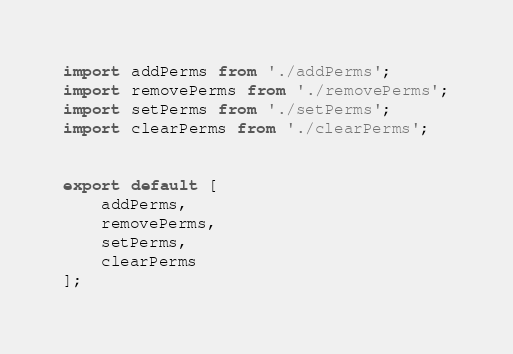Convert code to text. <code><loc_0><loc_0><loc_500><loc_500><_TypeScript_>import addPerms from './addPerms';
import removePerms from './removePerms';
import setPerms from './setPerms';
import clearPerms from './clearPerms';


export default [
    addPerms,
    removePerms,
    setPerms,
    clearPerms
];</code> 